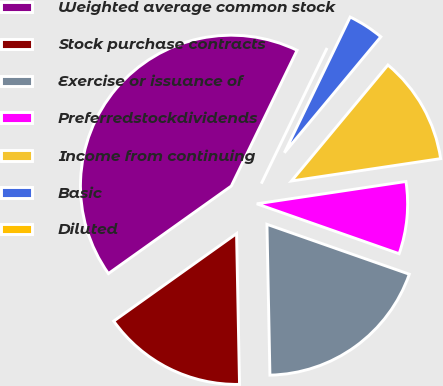<chart> <loc_0><loc_0><loc_500><loc_500><pie_chart><fcel>Weighted average common stock<fcel>Stock purchase contracts<fcel>Exercise or issuance of<fcel>Preferredstockdividends<fcel>Income from continuing<fcel>Basic<fcel>Diluted<nl><fcel>42.03%<fcel>15.46%<fcel>19.32%<fcel>7.73%<fcel>11.59%<fcel>3.86%<fcel>0.0%<nl></chart> 